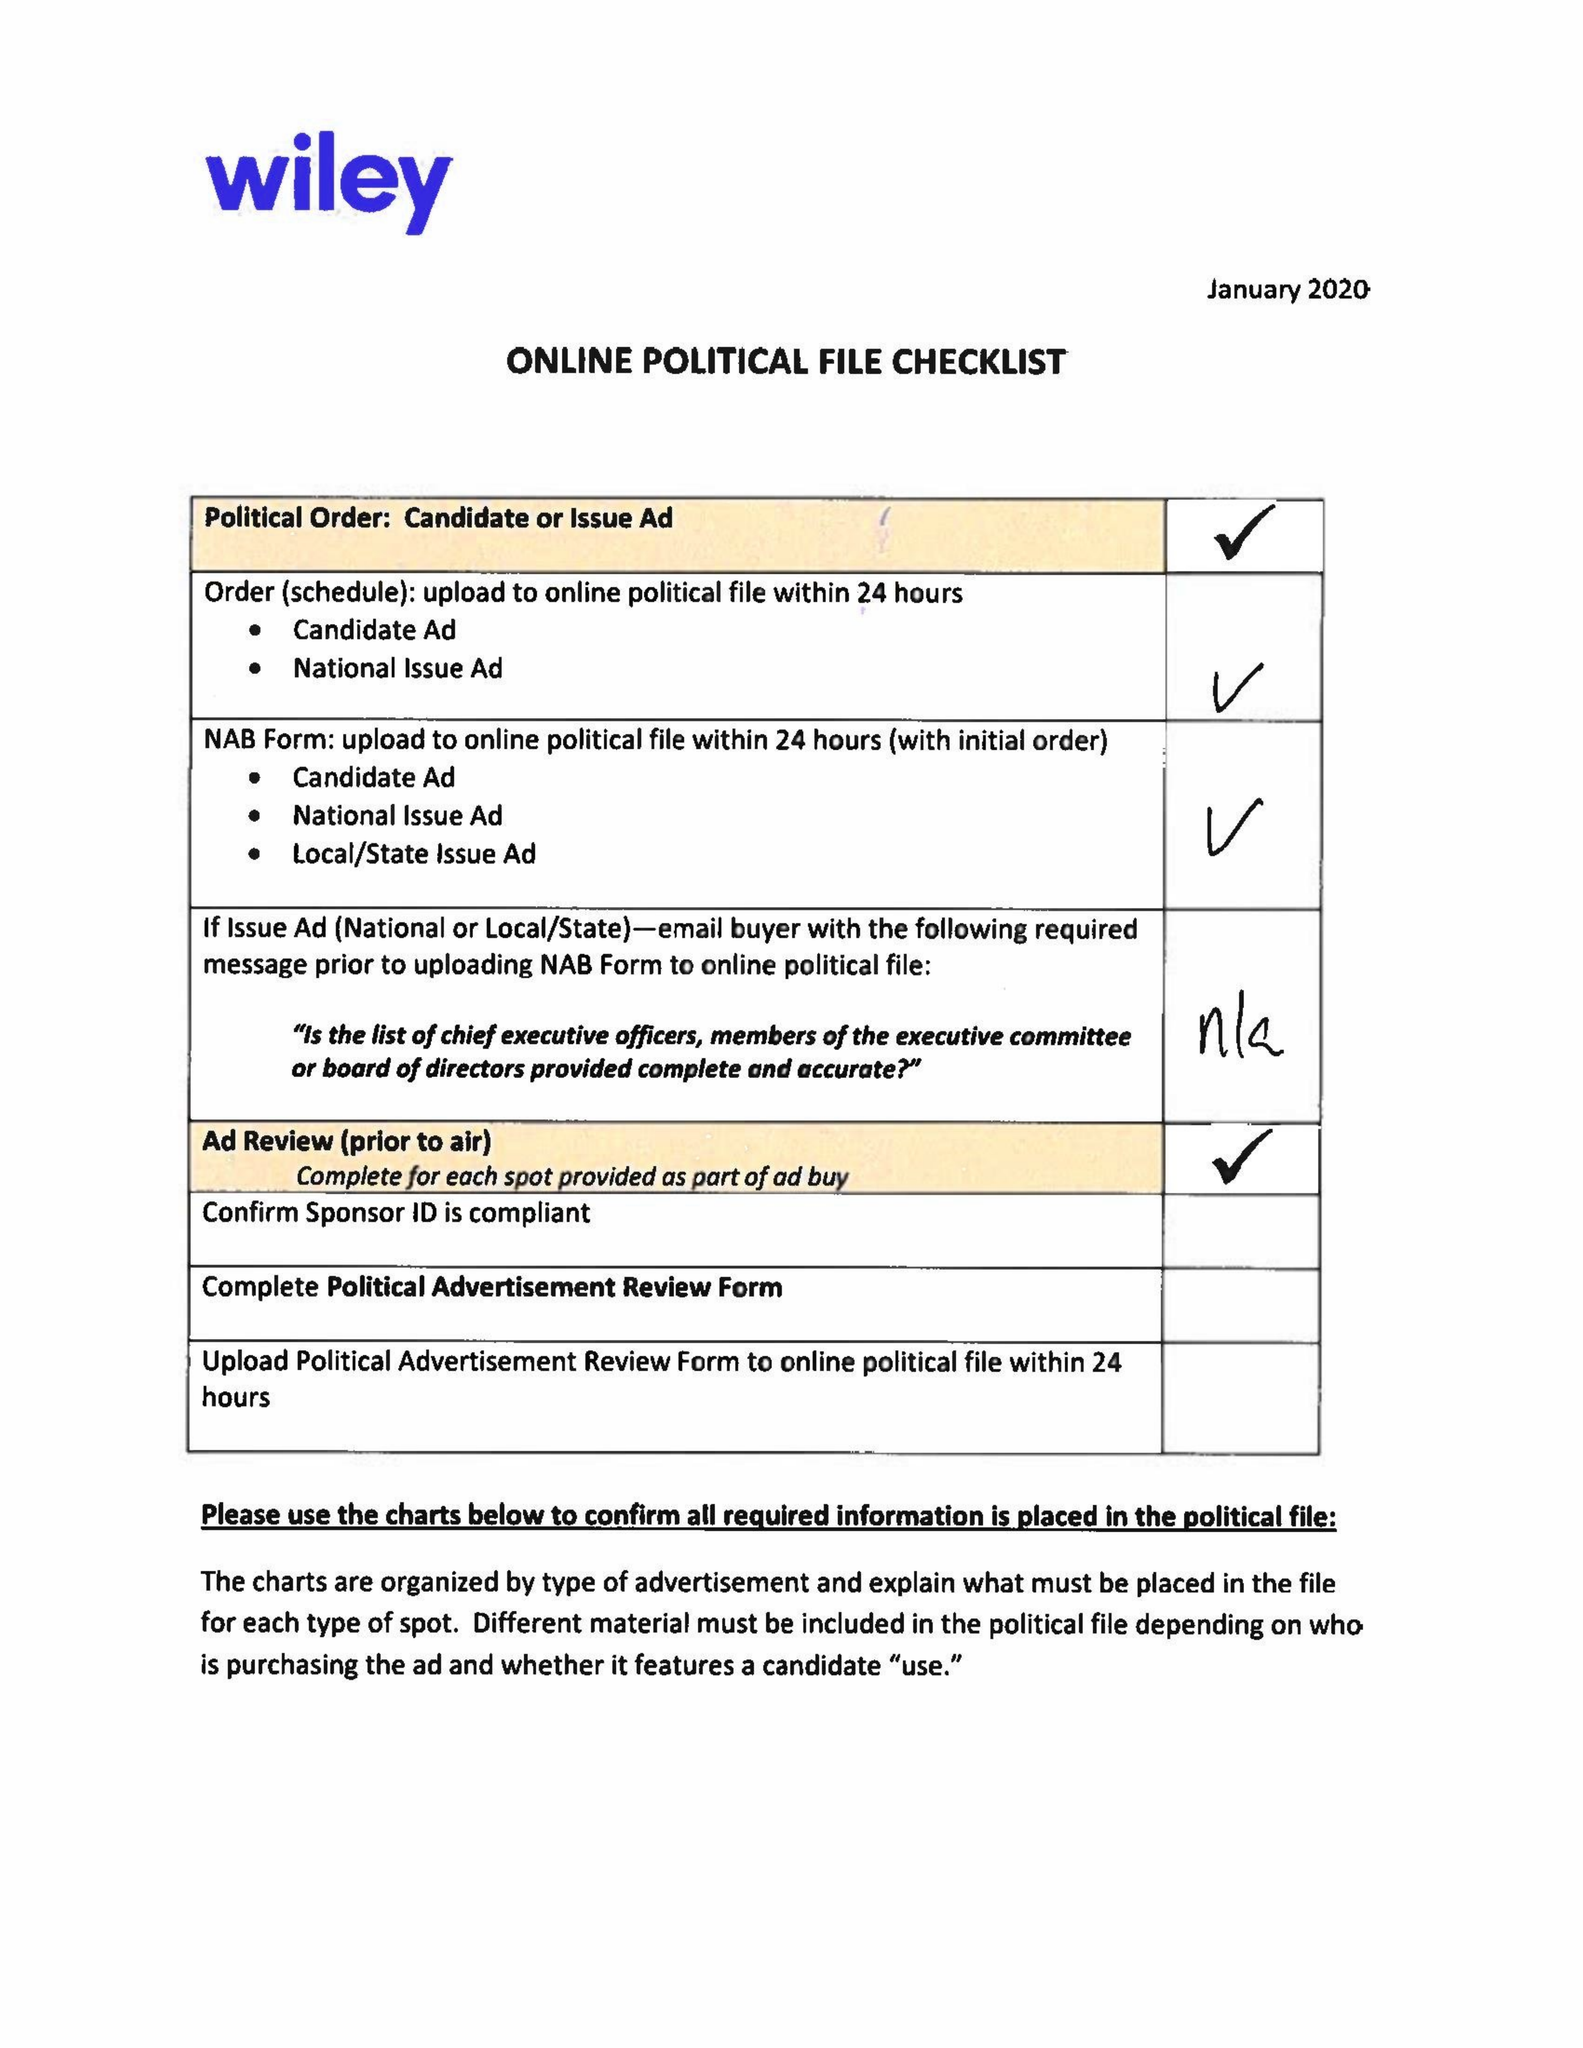What is the value for the flight_to?
Answer the question using a single word or phrase. 02/18/20 